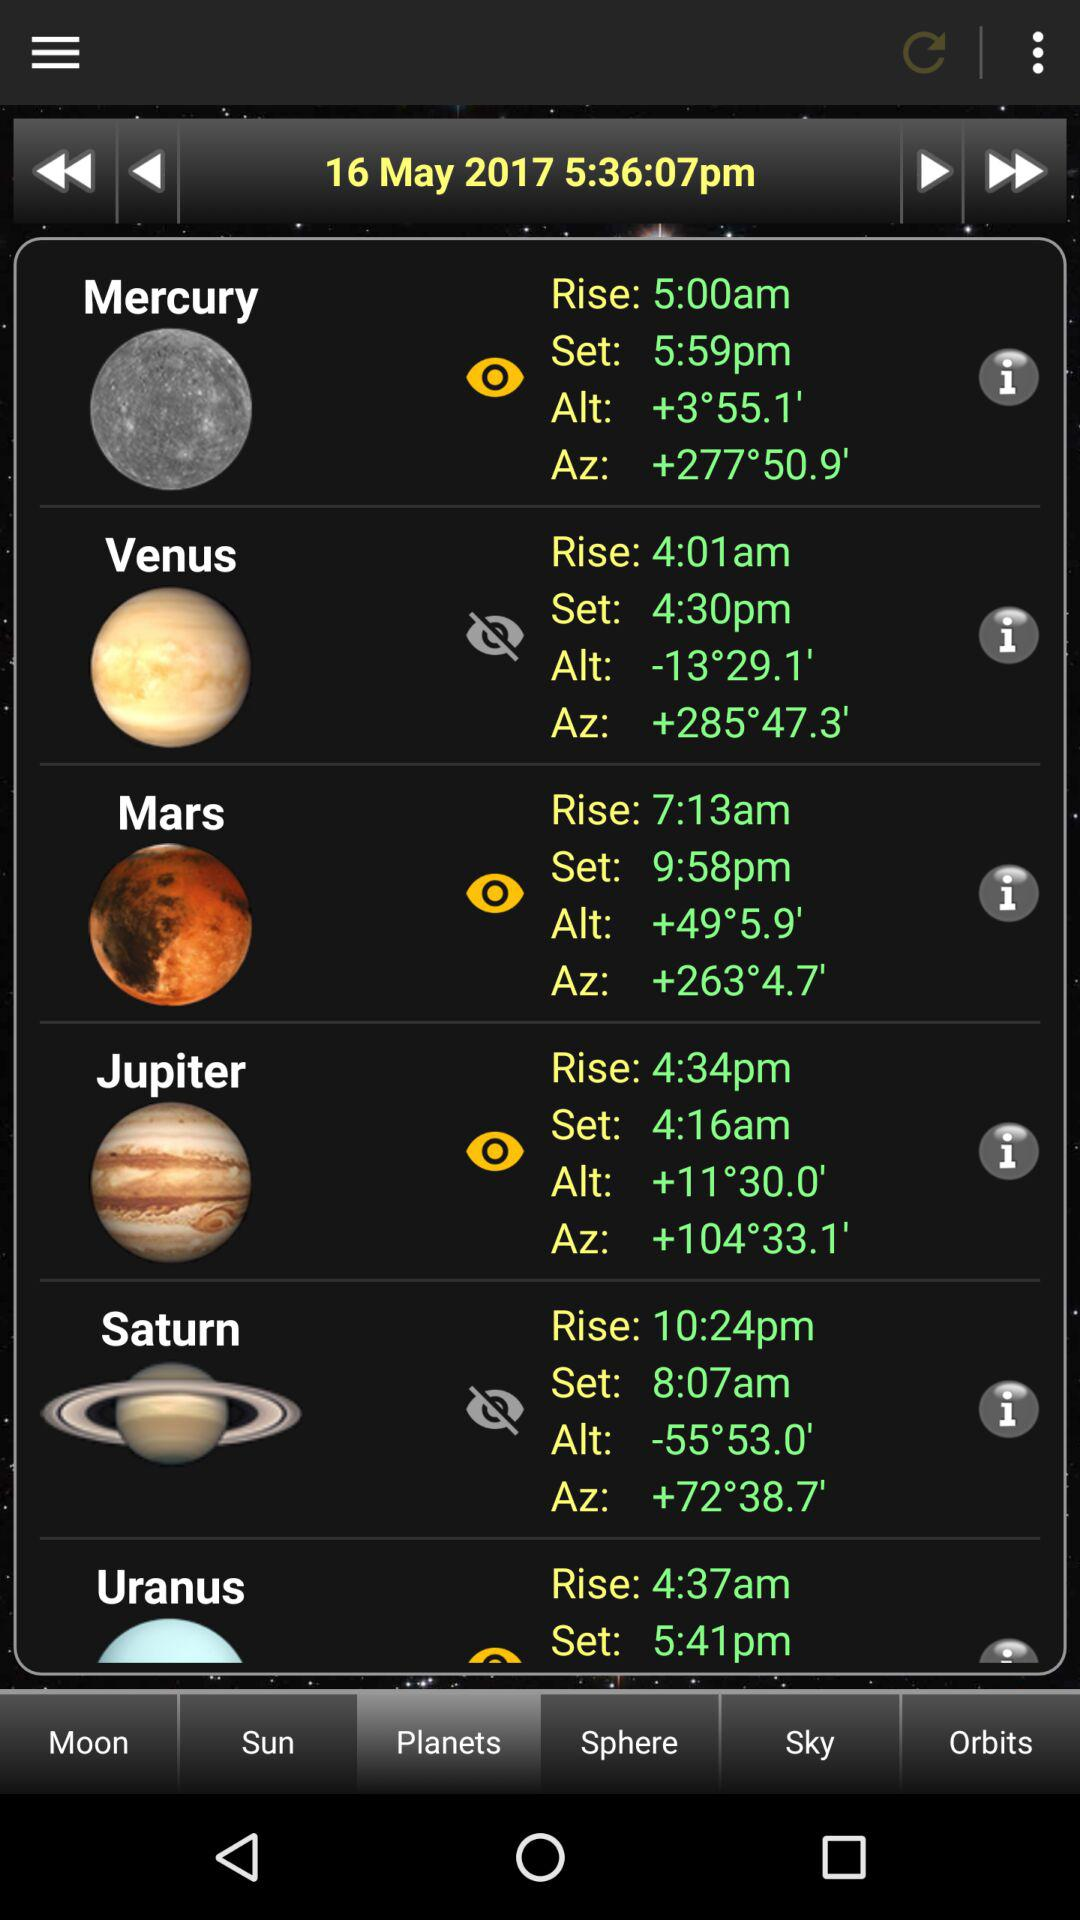How much is the "Alt" of Uranus?
When the provided information is insufficient, respond with <no answer>. <no answer> 